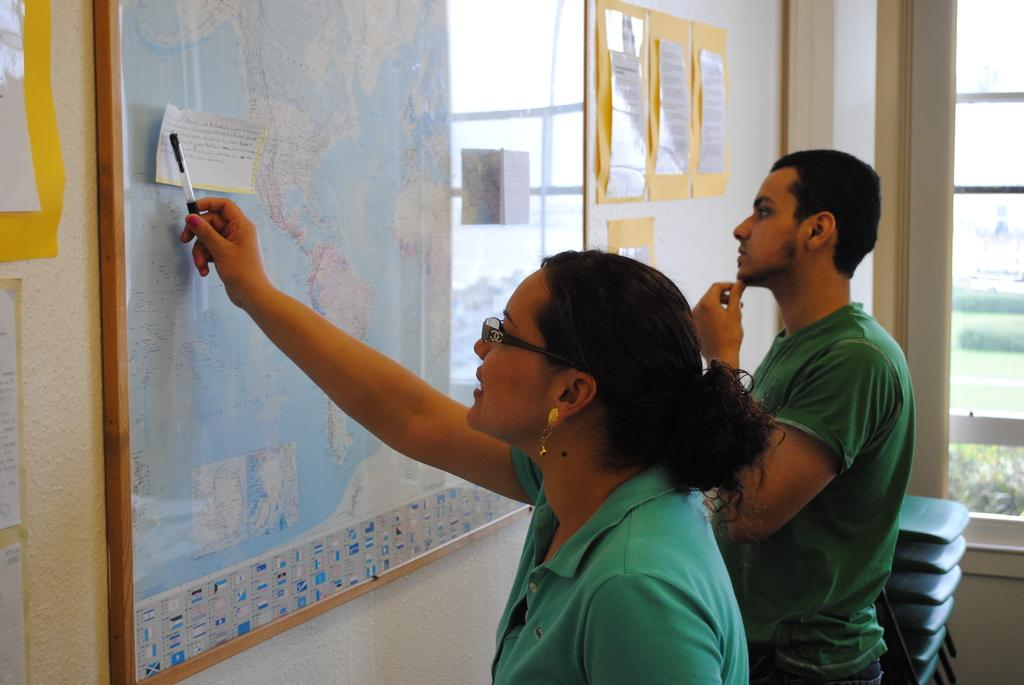How many people are present in the image? There is a man and a woman present in the image. What are they looking at in the image? They are looking at a map in front of them. What is attached to the wall in the image? Papers are attached to the wall. What can be seen through the window in the image? The contents of the window are not visible in the image. What type of furniture is on the right side of the image? There are chairs on the right side of the image. What type of toy is the man playing with in the image? There is no toy present in the image; the man is looking at a map with a woman. 